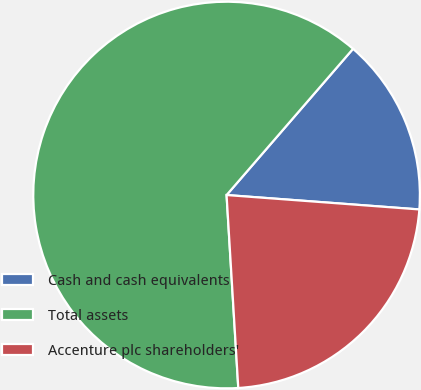<chart> <loc_0><loc_0><loc_500><loc_500><pie_chart><fcel>Cash and cash equivalents<fcel>Total assets<fcel>Accenture plc shareholders'<nl><fcel>14.84%<fcel>62.32%<fcel>22.85%<nl></chart> 